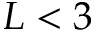<formula> <loc_0><loc_0><loc_500><loc_500>L < 3</formula> 